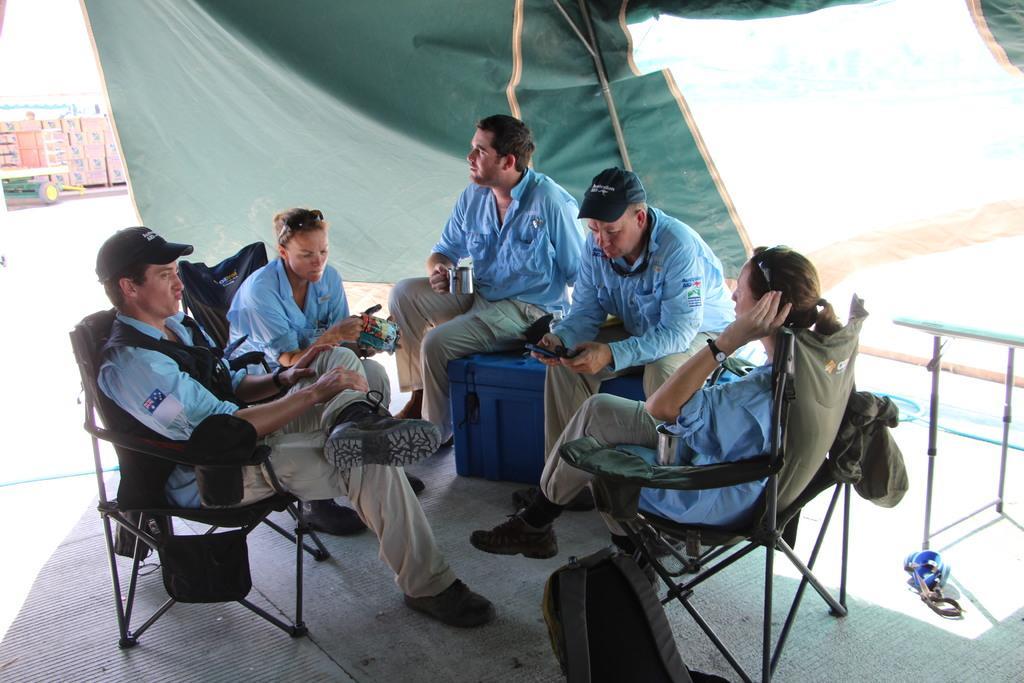Could you give a brief overview of what you see in this image? This is the picture of five people sitting in the tent among them there are sitting on the chairs and two are sitting on a box. 